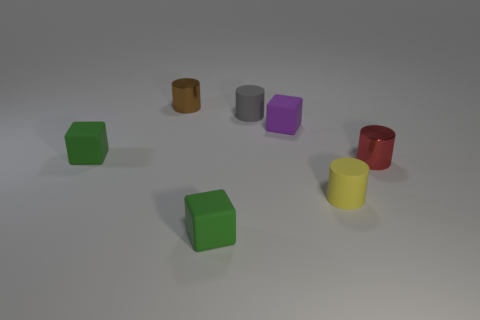Subtract all cyan cylinders. Subtract all gray spheres. How many cylinders are left? 4 Add 2 big red matte cubes. How many objects exist? 9 Subtract all cylinders. How many objects are left? 3 Add 1 tiny metallic cylinders. How many tiny metallic cylinders exist? 3 Subtract 0 gray blocks. How many objects are left? 7 Subtract all tiny yellow shiny cubes. Subtract all green matte blocks. How many objects are left? 5 Add 2 cylinders. How many cylinders are left? 6 